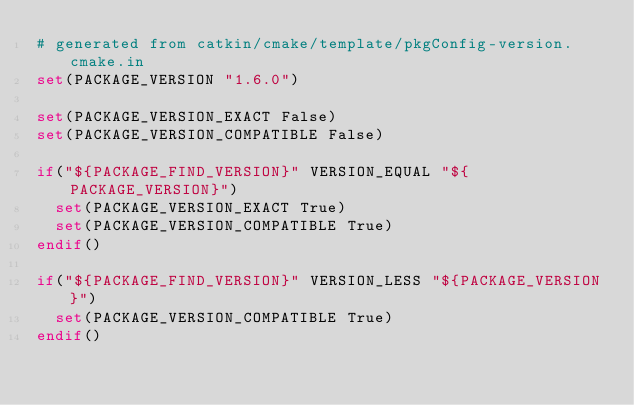Convert code to text. <code><loc_0><loc_0><loc_500><loc_500><_CMake_># generated from catkin/cmake/template/pkgConfig-version.cmake.in
set(PACKAGE_VERSION "1.6.0")

set(PACKAGE_VERSION_EXACT False)
set(PACKAGE_VERSION_COMPATIBLE False)

if("${PACKAGE_FIND_VERSION}" VERSION_EQUAL "${PACKAGE_VERSION}")
  set(PACKAGE_VERSION_EXACT True)
  set(PACKAGE_VERSION_COMPATIBLE True)
endif()

if("${PACKAGE_FIND_VERSION}" VERSION_LESS "${PACKAGE_VERSION}")
  set(PACKAGE_VERSION_COMPATIBLE True)
endif()
</code> 